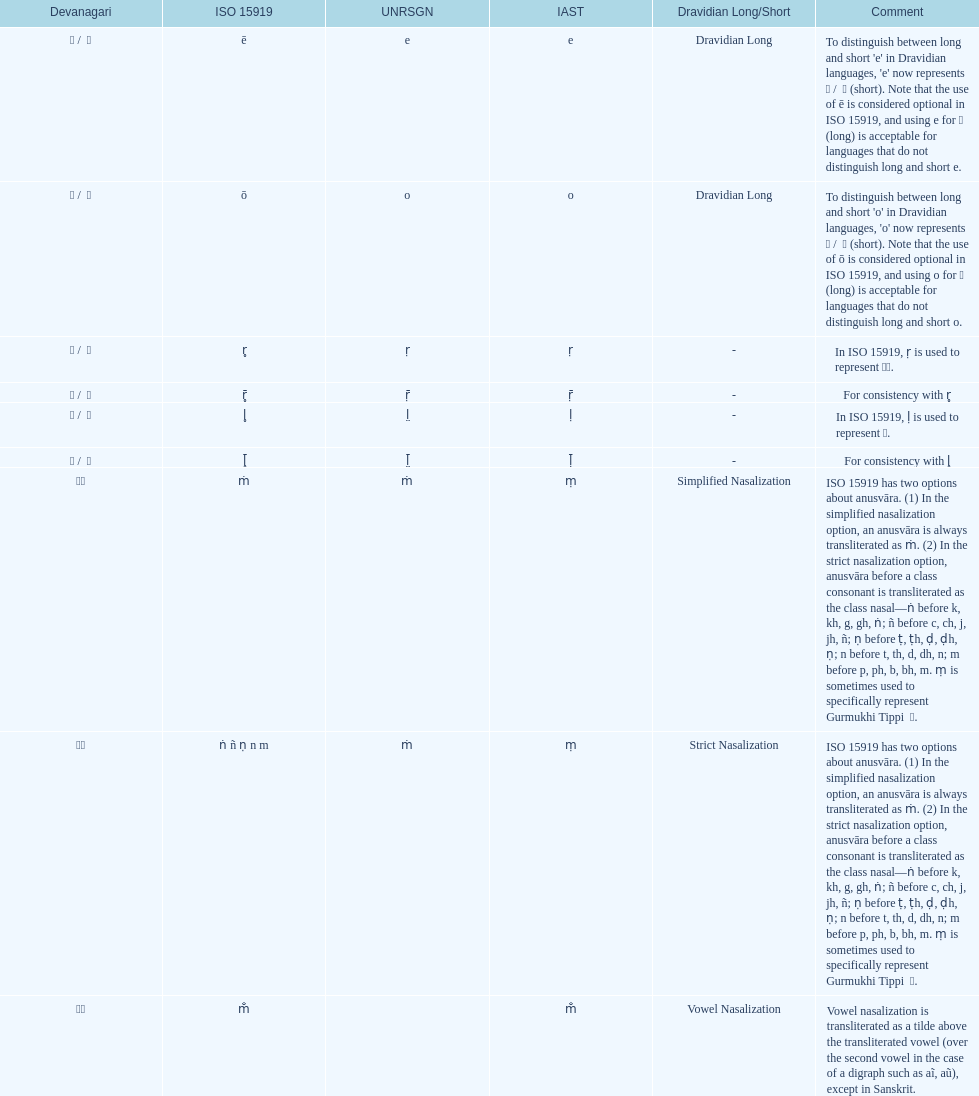What is the total number of translations? 8. 